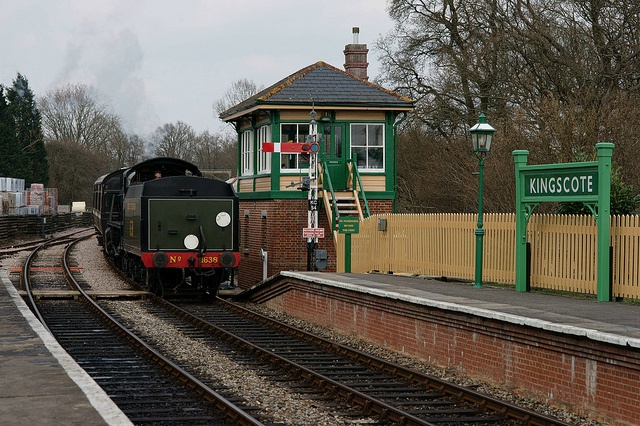Describe the objects in this image and their specific colors. I can see a train in lightgray, black, gray, and maroon tones in this image. 